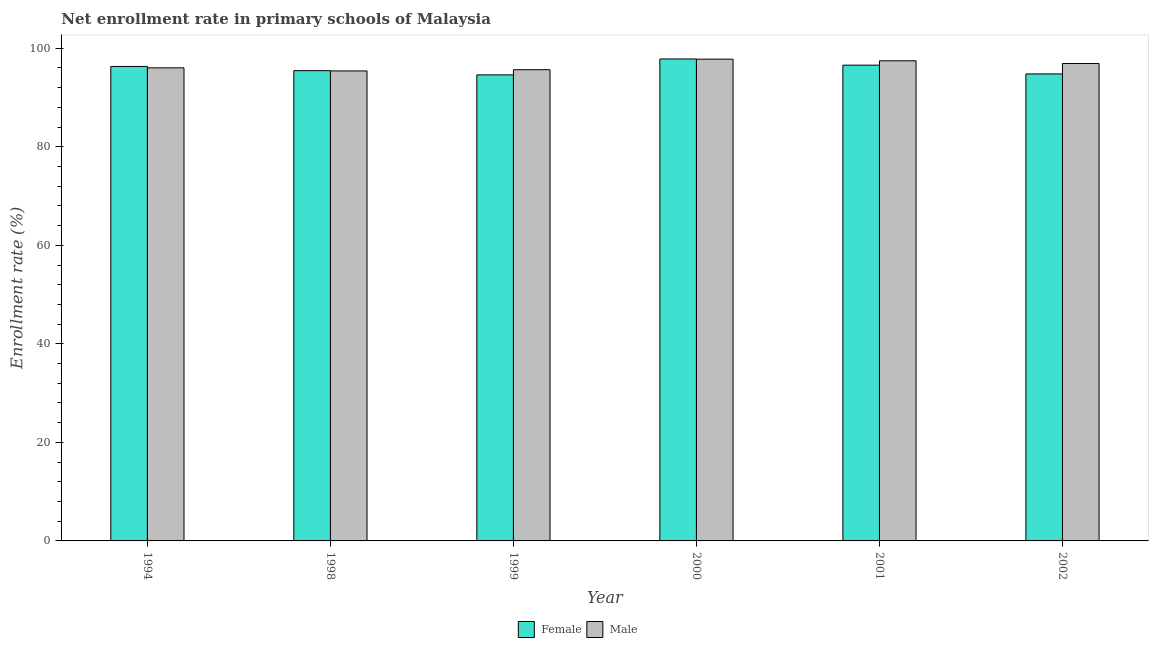How many different coloured bars are there?
Your response must be concise. 2. How many groups of bars are there?
Make the answer very short. 6. How many bars are there on the 1st tick from the left?
Your answer should be very brief. 2. How many bars are there on the 2nd tick from the right?
Offer a very short reply. 2. What is the label of the 6th group of bars from the left?
Your answer should be very brief. 2002. In how many cases, is the number of bars for a given year not equal to the number of legend labels?
Provide a short and direct response. 0. What is the enrollment rate of male students in 1994?
Provide a succinct answer. 96.03. Across all years, what is the maximum enrollment rate of female students?
Your response must be concise. 97.83. Across all years, what is the minimum enrollment rate of male students?
Ensure brevity in your answer.  95.4. What is the total enrollment rate of male students in the graph?
Your response must be concise. 579.26. What is the difference between the enrollment rate of male students in 1999 and that in 2001?
Make the answer very short. -1.81. What is the difference between the enrollment rate of female students in 1994 and the enrollment rate of male students in 1999?
Provide a short and direct response. 1.71. What is the average enrollment rate of female students per year?
Your answer should be compact. 95.93. What is the ratio of the enrollment rate of male students in 2000 to that in 2001?
Keep it short and to the point. 1. Is the enrollment rate of male students in 1994 less than that in 2000?
Offer a terse response. Yes. What is the difference between the highest and the second highest enrollment rate of female students?
Offer a very short reply. 1.26. What is the difference between the highest and the lowest enrollment rate of female students?
Give a very brief answer. 3.23. Is the sum of the enrollment rate of female students in 1998 and 2000 greater than the maximum enrollment rate of male students across all years?
Your response must be concise. Yes. What does the 2nd bar from the left in 1994 represents?
Ensure brevity in your answer.  Male. Does the graph contain grids?
Make the answer very short. No. How many legend labels are there?
Ensure brevity in your answer.  2. How are the legend labels stacked?
Offer a terse response. Horizontal. What is the title of the graph?
Your response must be concise. Net enrollment rate in primary schools of Malaysia. Does "Urban" appear as one of the legend labels in the graph?
Make the answer very short. No. What is the label or title of the X-axis?
Provide a short and direct response. Year. What is the label or title of the Y-axis?
Your answer should be compact. Enrollment rate (%). What is the Enrollment rate (%) in Female in 1994?
Your answer should be compact. 96.31. What is the Enrollment rate (%) of Male in 1994?
Your response must be concise. 96.03. What is the Enrollment rate (%) of Female in 1998?
Ensure brevity in your answer.  95.46. What is the Enrollment rate (%) in Male in 1998?
Your answer should be very brief. 95.4. What is the Enrollment rate (%) of Female in 1999?
Provide a succinct answer. 94.61. What is the Enrollment rate (%) in Male in 1999?
Give a very brief answer. 95.65. What is the Enrollment rate (%) of Female in 2000?
Provide a succinct answer. 97.83. What is the Enrollment rate (%) of Male in 2000?
Your answer should be very brief. 97.8. What is the Enrollment rate (%) of Female in 2001?
Keep it short and to the point. 96.57. What is the Enrollment rate (%) in Male in 2001?
Offer a terse response. 97.46. What is the Enrollment rate (%) in Female in 2002?
Your answer should be very brief. 94.8. What is the Enrollment rate (%) of Male in 2002?
Give a very brief answer. 96.91. Across all years, what is the maximum Enrollment rate (%) in Female?
Your response must be concise. 97.83. Across all years, what is the maximum Enrollment rate (%) in Male?
Ensure brevity in your answer.  97.8. Across all years, what is the minimum Enrollment rate (%) in Female?
Provide a succinct answer. 94.61. Across all years, what is the minimum Enrollment rate (%) in Male?
Offer a terse response. 95.4. What is the total Enrollment rate (%) of Female in the graph?
Your answer should be compact. 575.58. What is the total Enrollment rate (%) of Male in the graph?
Keep it short and to the point. 579.26. What is the difference between the Enrollment rate (%) in Female in 1994 and that in 1998?
Offer a terse response. 0.85. What is the difference between the Enrollment rate (%) in Male in 1994 and that in 1998?
Provide a short and direct response. 0.63. What is the difference between the Enrollment rate (%) of Female in 1994 and that in 1999?
Offer a terse response. 1.71. What is the difference between the Enrollment rate (%) of Male in 1994 and that in 1999?
Offer a very short reply. 0.38. What is the difference between the Enrollment rate (%) of Female in 1994 and that in 2000?
Provide a succinct answer. -1.52. What is the difference between the Enrollment rate (%) of Male in 1994 and that in 2000?
Your response must be concise. -1.77. What is the difference between the Enrollment rate (%) of Female in 1994 and that in 2001?
Make the answer very short. -0.26. What is the difference between the Enrollment rate (%) of Male in 1994 and that in 2001?
Give a very brief answer. -1.43. What is the difference between the Enrollment rate (%) in Female in 1994 and that in 2002?
Your answer should be very brief. 1.52. What is the difference between the Enrollment rate (%) of Male in 1994 and that in 2002?
Your answer should be compact. -0.88. What is the difference between the Enrollment rate (%) in Female in 1998 and that in 1999?
Make the answer very short. 0.85. What is the difference between the Enrollment rate (%) of Male in 1998 and that in 1999?
Provide a short and direct response. -0.25. What is the difference between the Enrollment rate (%) of Female in 1998 and that in 2000?
Ensure brevity in your answer.  -2.37. What is the difference between the Enrollment rate (%) of Male in 1998 and that in 2000?
Your answer should be compact. -2.39. What is the difference between the Enrollment rate (%) of Female in 1998 and that in 2001?
Ensure brevity in your answer.  -1.11. What is the difference between the Enrollment rate (%) in Male in 1998 and that in 2001?
Your response must be concise. -2.06. What is the difference between the Enrollment rate (%) in Female in 1998 and that in 2002?
Ensure brevity in your answer.  0.66. What is the difference between the Enrollment rate (%) of Male in 1998 and that in 2002?
Give a very brief answer. -1.5. What is the difference between the Enrollment rate (%) in Female in 1999 and that in 2000?
Provide a short and direct response. -3.23. What is the difference between the Enrollment rate (%) in Male in 1999 and that in 2000?
Ensure brevity in your answer.  -2.14. What is the difference between the Enrollment rate (%) in Female in 1999 and that in 2001?
Provide a succinct answer. -1.97. What is the difference between the Enrollment rate (%) of Male in 1999 and that in 2001?
Provide a succinct answer. -1.81. What is the difference between the Enrollment rate (%) of Female in 1999 and that in 2002?
Offer a terse response. -0.19. What is the difference between the Enrollment rate (%) of Male in 1999 and that in 2002?
Your answer should be very brief. -1.25. What is the difference between the Enrollment rate (%) in Female in 2000 and that in 2001?
Provide a succinct answer. 1.26. What is the difference between the Enrollment rate (%) in Male in 2000 and that in 2001?
Provide a succinct answer. 0.34. What is the difference between the Enrollment rate (%) of Female in 2000 and that in 2002?
Offer a very short reply. 3.04. What is the difference between the Enrollment rate (%) of Male in 2000 and that in 2002?
Make the answer very short. 0.89. What is the difference between the Enrollment rate (%) of Female in 2001 and that in 2002?
Provide a short and direct response. 1.78. What is the difference between the Enrollment rate (%) of Male in 2001 and that in 2002?
Make the answer very short. 0.55. What is the difference between the Enrollment rate (%) in Female in 1994 and the Enrollment rate (%) in Male in 1998?
Make the answer very short. 0.91. What is the difference between the Enrollment rate (%) in Female in 1994 and the Enrollment rate (%) in Male in 1999?
Keep it short and to the point. 0.66. What is the difference between the Enrollment rate (%) of Female in 1994 and the Enrollment rate (%) of Male in 2000?
Make the answer very short. -1.48. What is the difference between the Enrollment rate (%) in Female in 1994 and the Enrollment rate (%) in Male in 2001?
Keep it short and to the point. -1.15. What is the difference between the Enrollment rate (%) of Female in 1994 and the Enrollment rate (%) of Male in 2002?
Ensure brevity in your answer.  -0.59. What is the difference between the Enrollment rate (%) in Female in 1998 and the Enrollment rate (%) in Male in 1999?
Offer a terse response. -0.19. What is the difference between the Enrollment rate (%) in Female in 1998 and the Enrollment rate (%) in Male in 2000?
Your answer should be very brief. -2.34. What is the difference between the Enrollment rate (%) of Female in 1998 and the Enrollment rate (%) of Male in 2001?
Your answer should be compact. -2. What is the difference between the Enrollment rate (%) of Female in 1998 and the Enrollment rate (%) of Male in 2002?
Make the answer very short. -1.45. What is the difference between the Enrollment rate (%) of Female in 1999 and the Enrollment rate (%) of Male in 2000?
Make the answer very short. -3.19. What is the difference between the Enrollment rate (%) of Female in 1999 and the Enrollment rate (%) of Male in 2001?
Provide a succinct answer. -2.86. What is the difference between the Enrollment rate (%) of Female in 1999 and the Enrollment rate (%) of Male in 2002?
Your answer should be very brief. -2.3. What is the difference between the Enrollment rate (%) in Female in 2000 and the Enrollment rate (%) in Male in 2001?
Provide a succinct answer. 0.37. What is the difference between the Enrollment rate (%) in Female in 2000 and the Enrollment rate (%) in Male in 2002?
Your answer should be compact. 0.92. What is the difference between the Enrollment rate (%) in Female in 2001 and the Enrollment rate (%) in Male in 2002?
Provide a short and direct response. -0.33. What is the average Enrollment rate (%) of Female per year?
Your response must be concise. 95.93. What is the average Enrollment rate (%) of Male per year?
Offer a very short reply. 96.54. In the year 1994, what is the difference between the Enrollment rate (%) in Female and Enrollment rate (%) in Male?
Ensure brevity in your answer.  0.28. In the year 1998, what is the difference between the Enrollment rate (%) of Female and Enrollment rate (%) of Male?
Your answer should be compact. 0.06. In the year 1999, what is the difference between the Enrollment rate (%) in Female and Enrollment rate (%) in Male?
Your answer should be very brief. -1.05. In the year 2000, what is the difference between the Enrollment rate (%) of Female and Enrollment rate (%) of Male?
Give a very brief answer. 0.03. In the year 2001, what is the difference between the Enrollment rate (%) of Female and Enrollment rate (%) of Male?
Your response must be concise. -0.89. In the year 2002, what is the difference between the Enrollment rate (%) in Female and Enrollment rate (%) in Male?
Your answer should be compact. -2.11. What is the ratio of the Enrollment rate (%) of Female in 1994 to that in 1998?
Your answer should be very brief. 1.01. What is the ratio of the Enrollment rate (%) of Male in 1994 to that in 1998?
Provide a short and direct response. 1.01. What is the ratio of the Enrollment rate (%) in Female in 1994 to that in 1999?
Your answer should be compact. 1.02. What is the ratio of the Enrollment rate (%) in Female in 1994 to that in 2000?
Ensure brevity in your answer.  0.98. What is the ratio of the Enrollment rate (%) in Male in 1994 to that in 2000?
Ensure brevity in your answer.  0.98. What is the ratio of the Enrollment rate (%) of Female in 1994 to that in 2001?
Make the answer very short. 1. What is the ratio of the Enrollment rate (%) in Male in 1994 to that in 2001?
Provide a succinct answer. 0.99. What is the ratio of the Enrollment rate (%) of Female in 1994 to that in 2002?
Your answer should be very brief. 1.02. What is the ratio of the Enrollment rate (%) in Male in 1994 to that in 2002?
Ensure brevity in your answer.  0.99. What is the ratio of the Enrollment rate (%) in Female in 1998 to that in 2000?
Keep it short and to the point. 0.98. What is the ratio of the Enrollment rate (%) in Male in 1998 to that in 2000?
Ensure brevity in your answer.  0.98. What is the ratio of the Enrollment rate (%) of Female in 1998 to that in 2001?
Offer a very short reply. 0.99. What is the ratio of the Enrollment rate (%) in Male in 1998 to that in 2001?
Your answer should be compact. 0.98. What is the ratio of the Enrollment rate (%) of Female in 1998 to that in 2002?
Your answer should be compact. 1.01. What is the ratio of the Enrollment rate (%) of Male in 1998 to that in 2002?
Give a very brief answer. 0.98. What is the ratio of the Enrollment rate (%) in Male in 1999 to that in 2000?
Provide a succinct answer. 0.98. What is the ratio of the Enrollment rate (%) in Female in 1999 to that in 2001?
Your response must be concise. 0.98. What is the ratio of the Enrollment rate (%) of Male in 1999 to that in 2001?
Your response must be concise. 0.98. What is the ratio of the Enrollment rate (%) of Male in 1999 to that in 2002?
Offer a very short reply. 0.99. What is the ratio of the Enrollment rate (%) of Male in 2000 to that in 2001?
Offer a terse response. 1. What is the ratio of the Enrollment rate (%) of Female in 2000 to that in 2002?
Your response must be concise. 1.03. What is the ratio of the Enrollment rate (%) in Male in 2000 to that in 2002?
Provide a succinct answer. 1.01. What is the ratio of the Enrollment rate (%) of Female in 2001 to that in 2002?
Provide a short and direct response. 1.02. What is the ratio of the Enrollment rate (%) in Male in 2001 to that in 2002?
Your answer should be compact. 1.01. What is the difference between the highest and the second highest Enrollment rate (%) in Female?
Offer a terse response. 1.26. What is the difference between the highest and the second highest Enrollment rate (%) of Male?
Your answer should be compact. 0.34. What is the difference between the highest and the lowest Enrollment rate (%) of Female?
Provide a short and direct response. 3.23. What is the difference between the highest and the lowest Enrollment rate (%) in Male?
Your answer should be very brief. 2.39. 